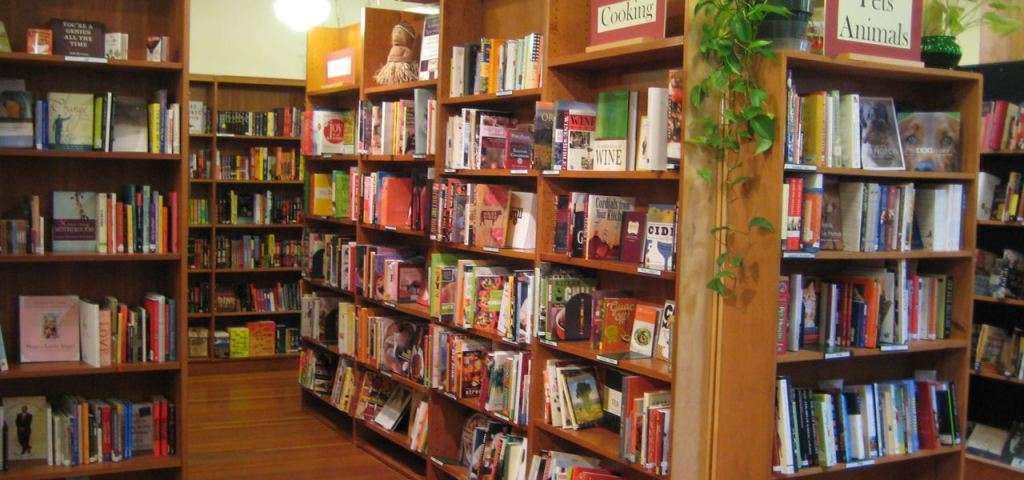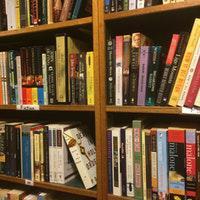The first image is the image on the left, the second image is the image on the right. Considering the images on both sides, is "There is at least one person sitting in front of a bookshelf with at least 10 books." valid? Answer yes or no. No. The first image is the image on the left, the second image is the image on the right. For the images displayed, is the sentence "The man behind the counter has a beard." factually correct? Answer yes or no. No. 